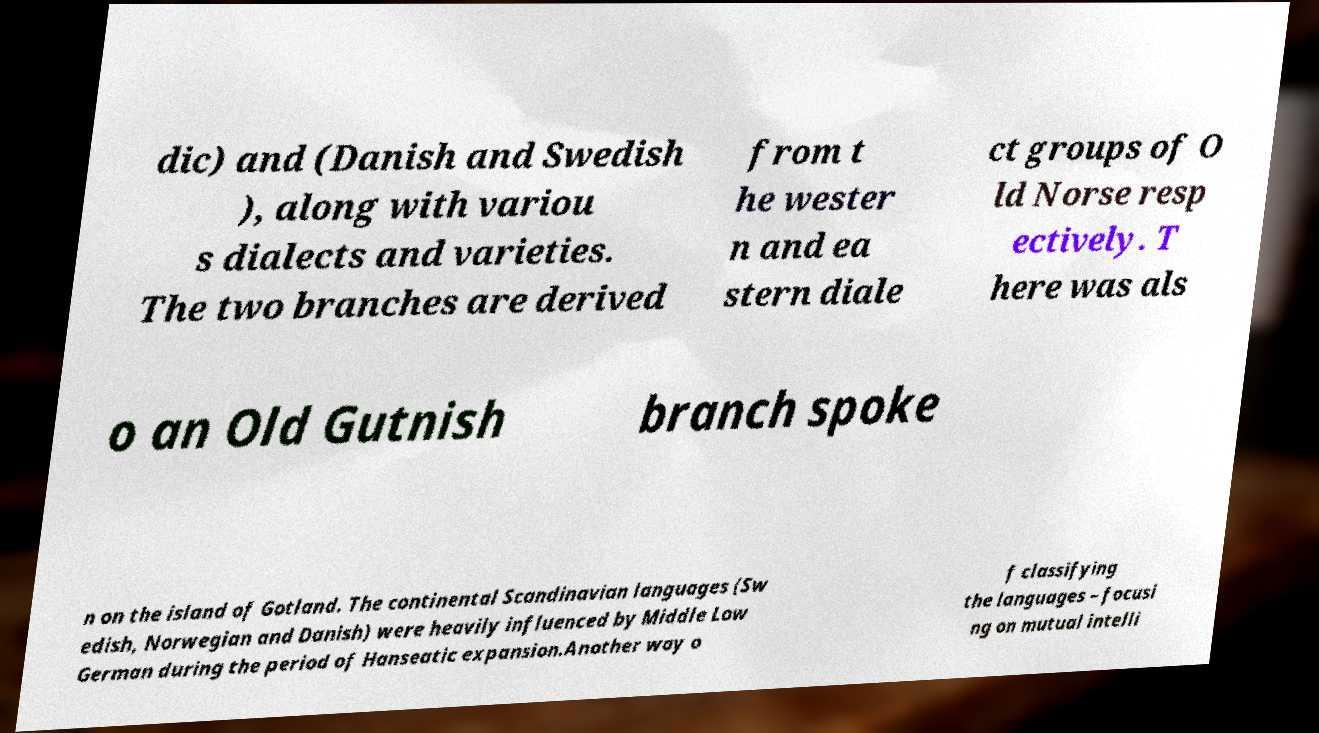What messages or text are displayed in this image? I need them in a readable, typed format. dic) and (Danish and Swedish ), along with variou s dialects and varieties. The two branches are derived from t he wester n and ea stern diale ct groups of O ld Norse resp ectively. T here was als o an Old Gutnish branch spoke n on the island of Gotland. The continental Scandinavian languages (Sw edish, Norwegian and Danish) were heavily influenced by Middle Low German during the period of Hanseatic expansion.Another way o f classifying the languages – focusi ng on mutual intelli 